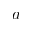Convert formula to latex. <formula><loc_0><loc_0><loc_500><loc_500>a</formula> 